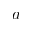Convert formula to latex. <formula><loc_0><loc_0><loc_500><loc_500>a</formula> 